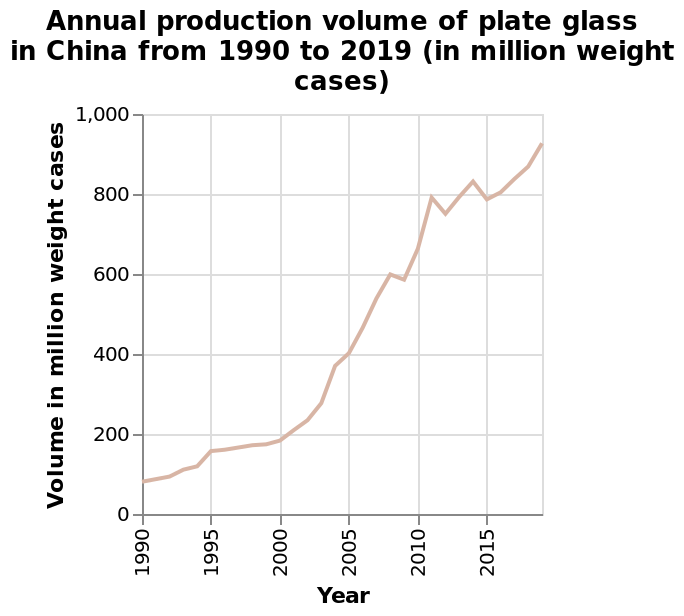<image>
What does the line graph show? The line graph shows the annual production volume of plate glass in China over the years from 1990 to 2019. 